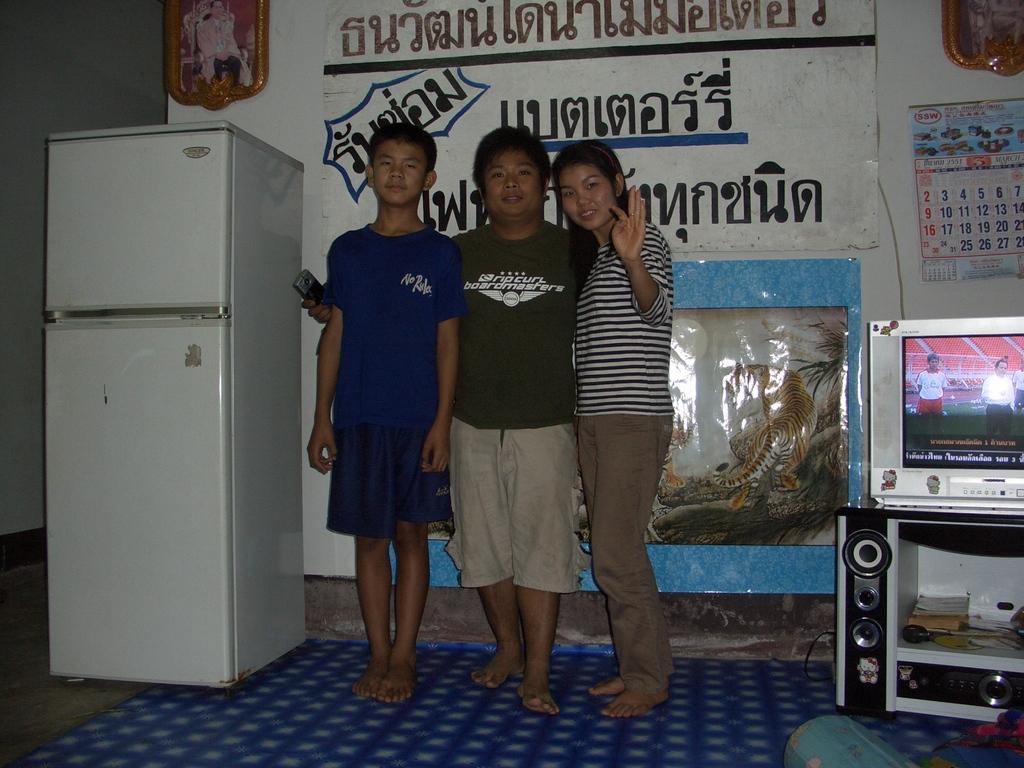Could you give a brief overview of what you see in this image? In this image I can see three persons are standing. I can see two of them are wearing shorts and one is wearing pant. Here I can see few speakers, a television, a calendar, a refrigerator and on this wall I can see something is written. 